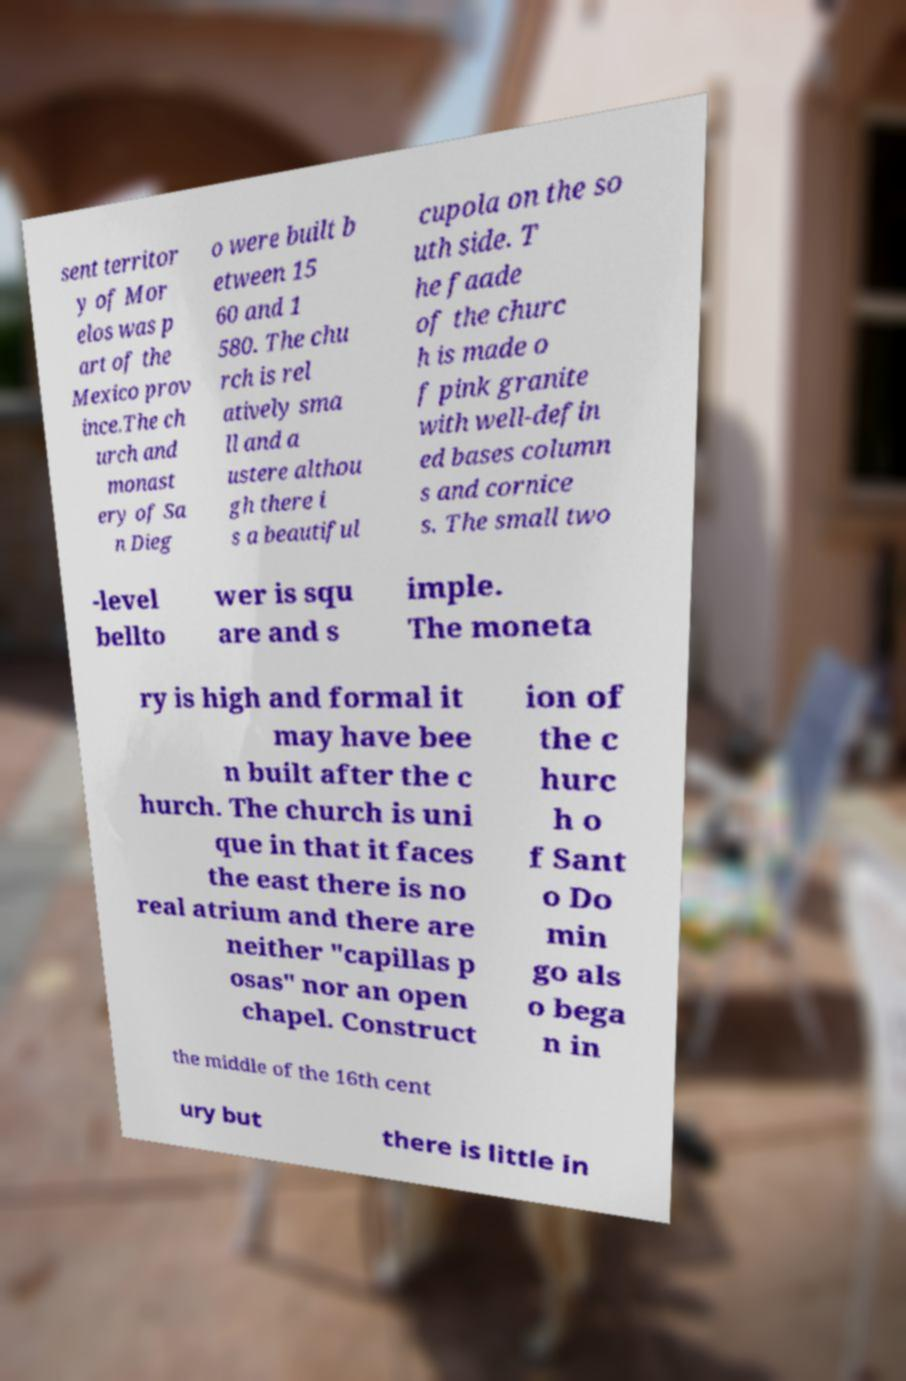Could you assist in decoding the text presented in this image and type it out clearly? sent territor y of Mor elos was p art of the Mexico prov ince.The ch urch and monast ery of Sa n Dieg o were built b etween 15 60 and 1 580. The chu rch is rel atively sma ll and a ustere althou gh there i s a beautiful cupola on the so uth side. T he faade of the churc h is made o f pink granite with well-defin ed bases column s and cornice s. The small two -level bellto wer is squ are and s imple. The moneta ry is high and formal it may have bee n built after the c hurch. The church is uni que in that it faces the east there is no real atrium and there are neither "capillas p osas" nor an open chapel. Construct ion of the c hurc h o f Sant o Do min go als o bega n in the middle of the 16th cent ury but there is little in 